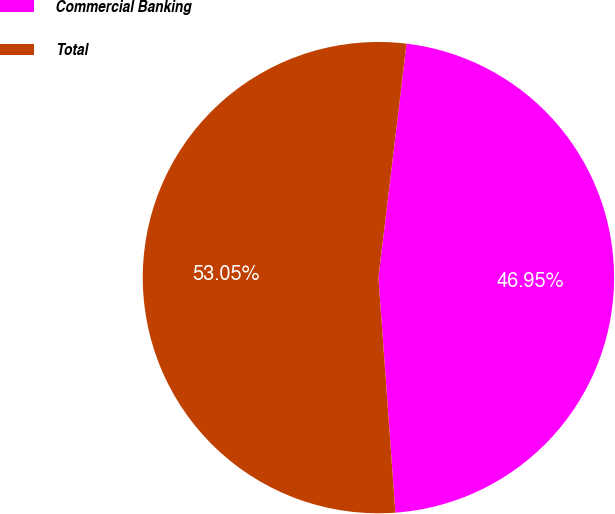Convert chart to OTSL. <chart><loc_0><loc_0><loc_500><loc_500><pie_chart><fcel>Commercial Banking<fcel>Total<nl><fcel>46.95%<fcel>53.05%<nl></chart> 